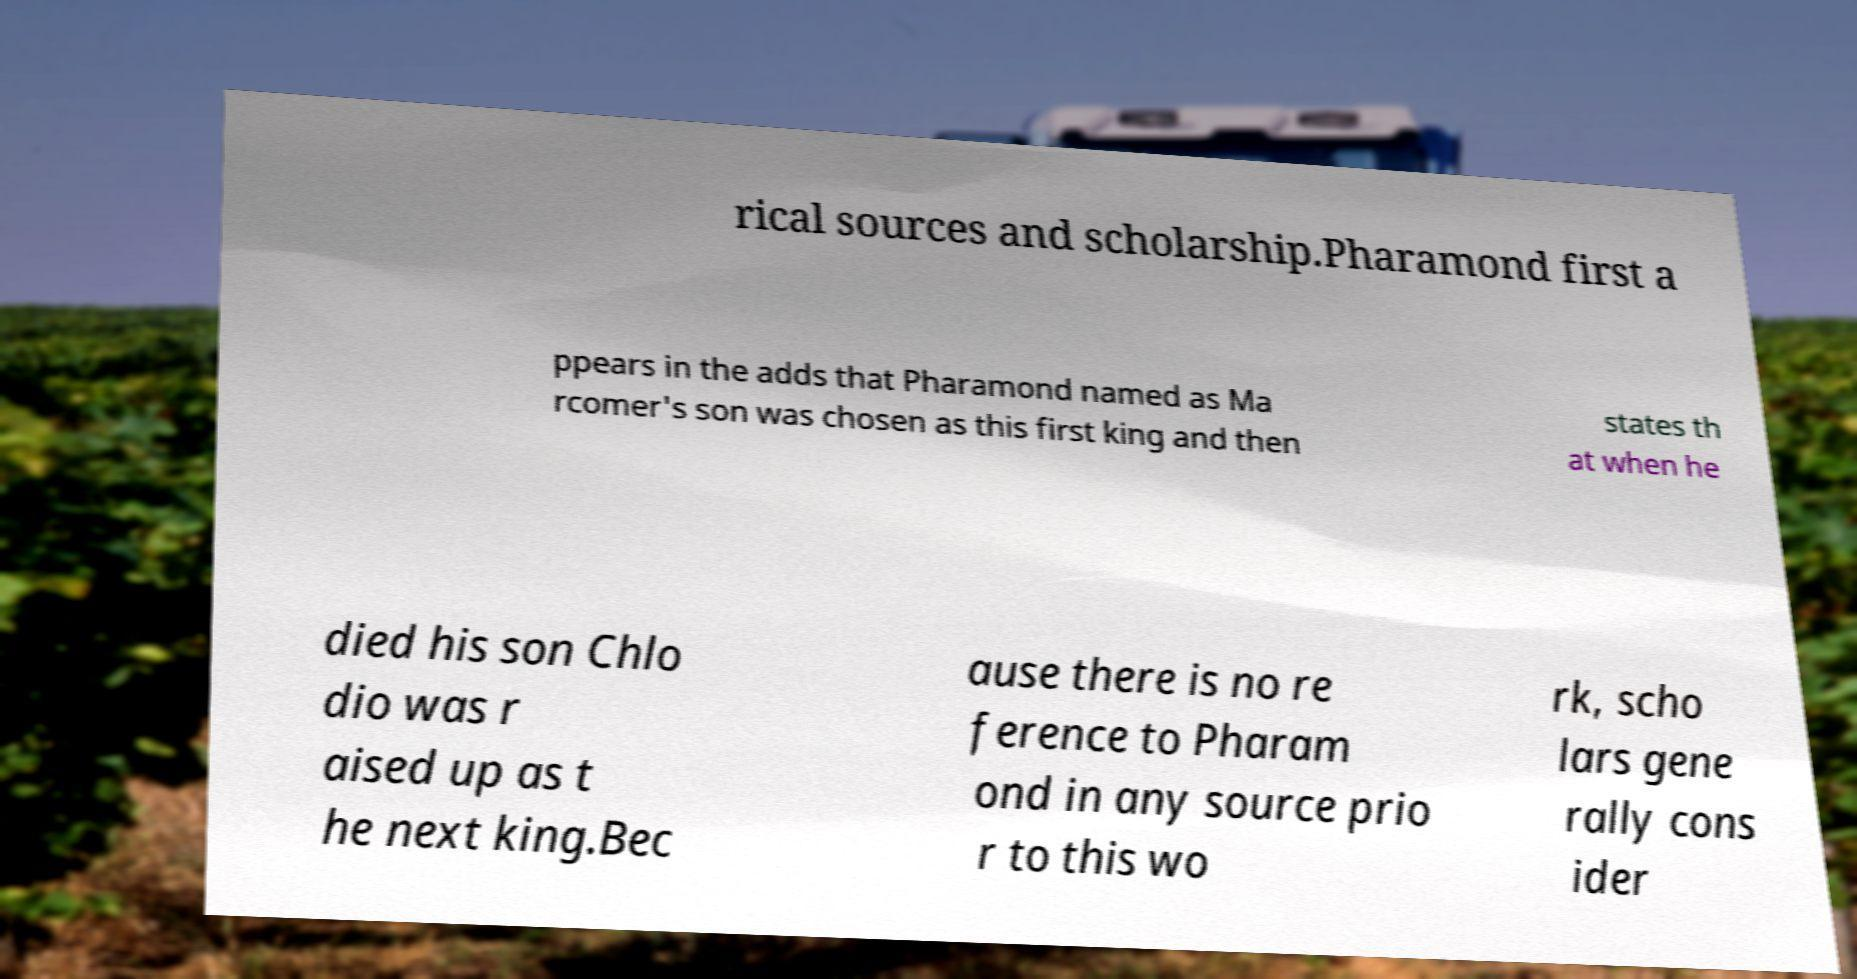Can you accurately transcribe the text from the provided image for me? rical sources and scholarship.Pharamond first a ppears in the adds that Pharamond named as Ma rcomer's son was chosen as this first king and then states th at when he died his son Chlo dio was r aised up as t he next king.Bec ause there is no re ference to Pharam ond in any source prio r to this wo rk, scho lars gene rally cons ider 